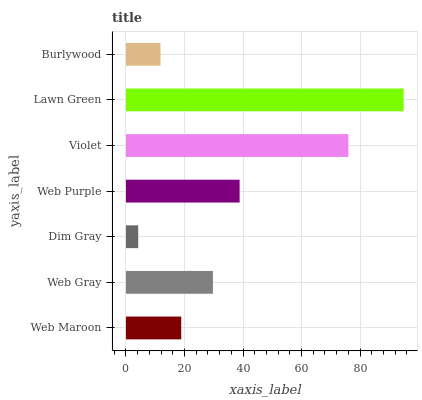Is Dim Gray the minimum?
Answer yes or no. Yes. Is Lawn Green the maximum?
Answer yes or no. Yes. Is Web Gray the minimum?
Answer yes or no. No. Is Web Gray the maximum?
Answer yes or no. No. Is Web Gray greater than Web Maroon?
Answer yes or no. Yes. Is Web Maroon less than Web Gray?
Answer yes or no. Yes. Is Web Maroon greater than Web Gray?
Answer yes or no. No. Is Web Gray less than Web Maroon?
Answer yes or no. No. Is Web Gray the high median?
Answer yes or no. Yes. Is Web Gray the low median?
Answer yes or no. Yes. Is Lawn Green the high median?
Answer yes or no. No. Is Web Maroon the low median?
Answer yes or no. No. 